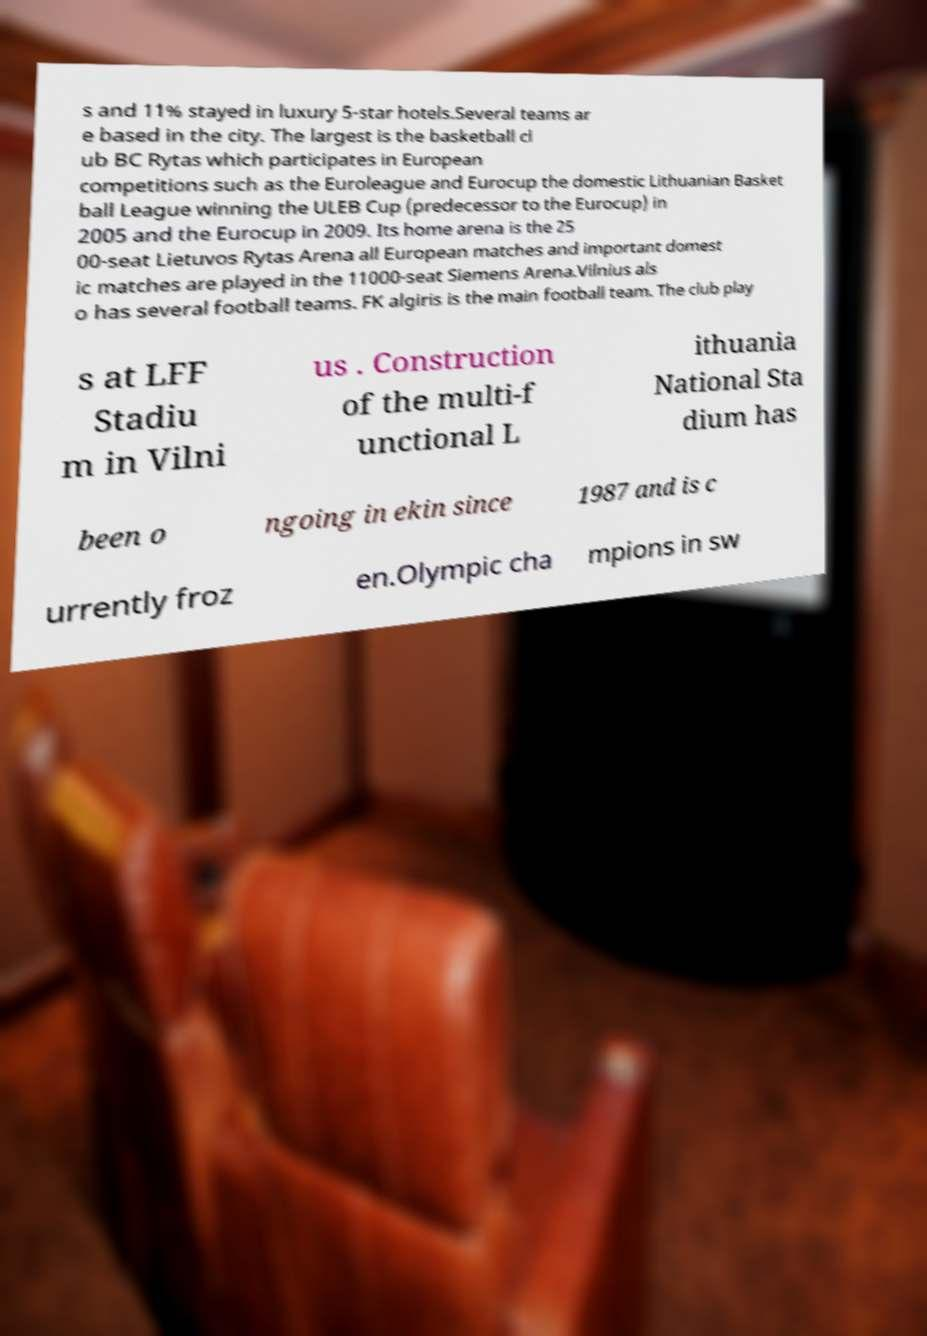For documentation purposes, I need the text within this image transcribed. Could you provide that? s and 11% stayed in luxury 5-star hotels.Several teams ar e based in the city. The largest is the basketball cl ub BC Rytas which participates in European competitions such as the Euroleague and Eurocup the domestic Lithuanian Basket ball League winning the ULEB Cup (predecessor to the Eurocup) in 2005 and the Eurocup in 2009. Its home arena is the 25 00-seat Lietuvos Rytas Arena all European matches and important domest ic matches are played in the 11000-seat Siemens Arena.Vilnius als o has several football teams. FK algiris is the main football team. The club play s at LFF Stadiu m in Vilni us . Construction of the multi-f unctional L ithuania National Sta dium has been o ngoing in ekin since 1987 and is c urrently froz en.Olympic cha mpions in sw 